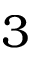<formula> <loc_0><loc_0><loc_500><loc_500>3</formula> 